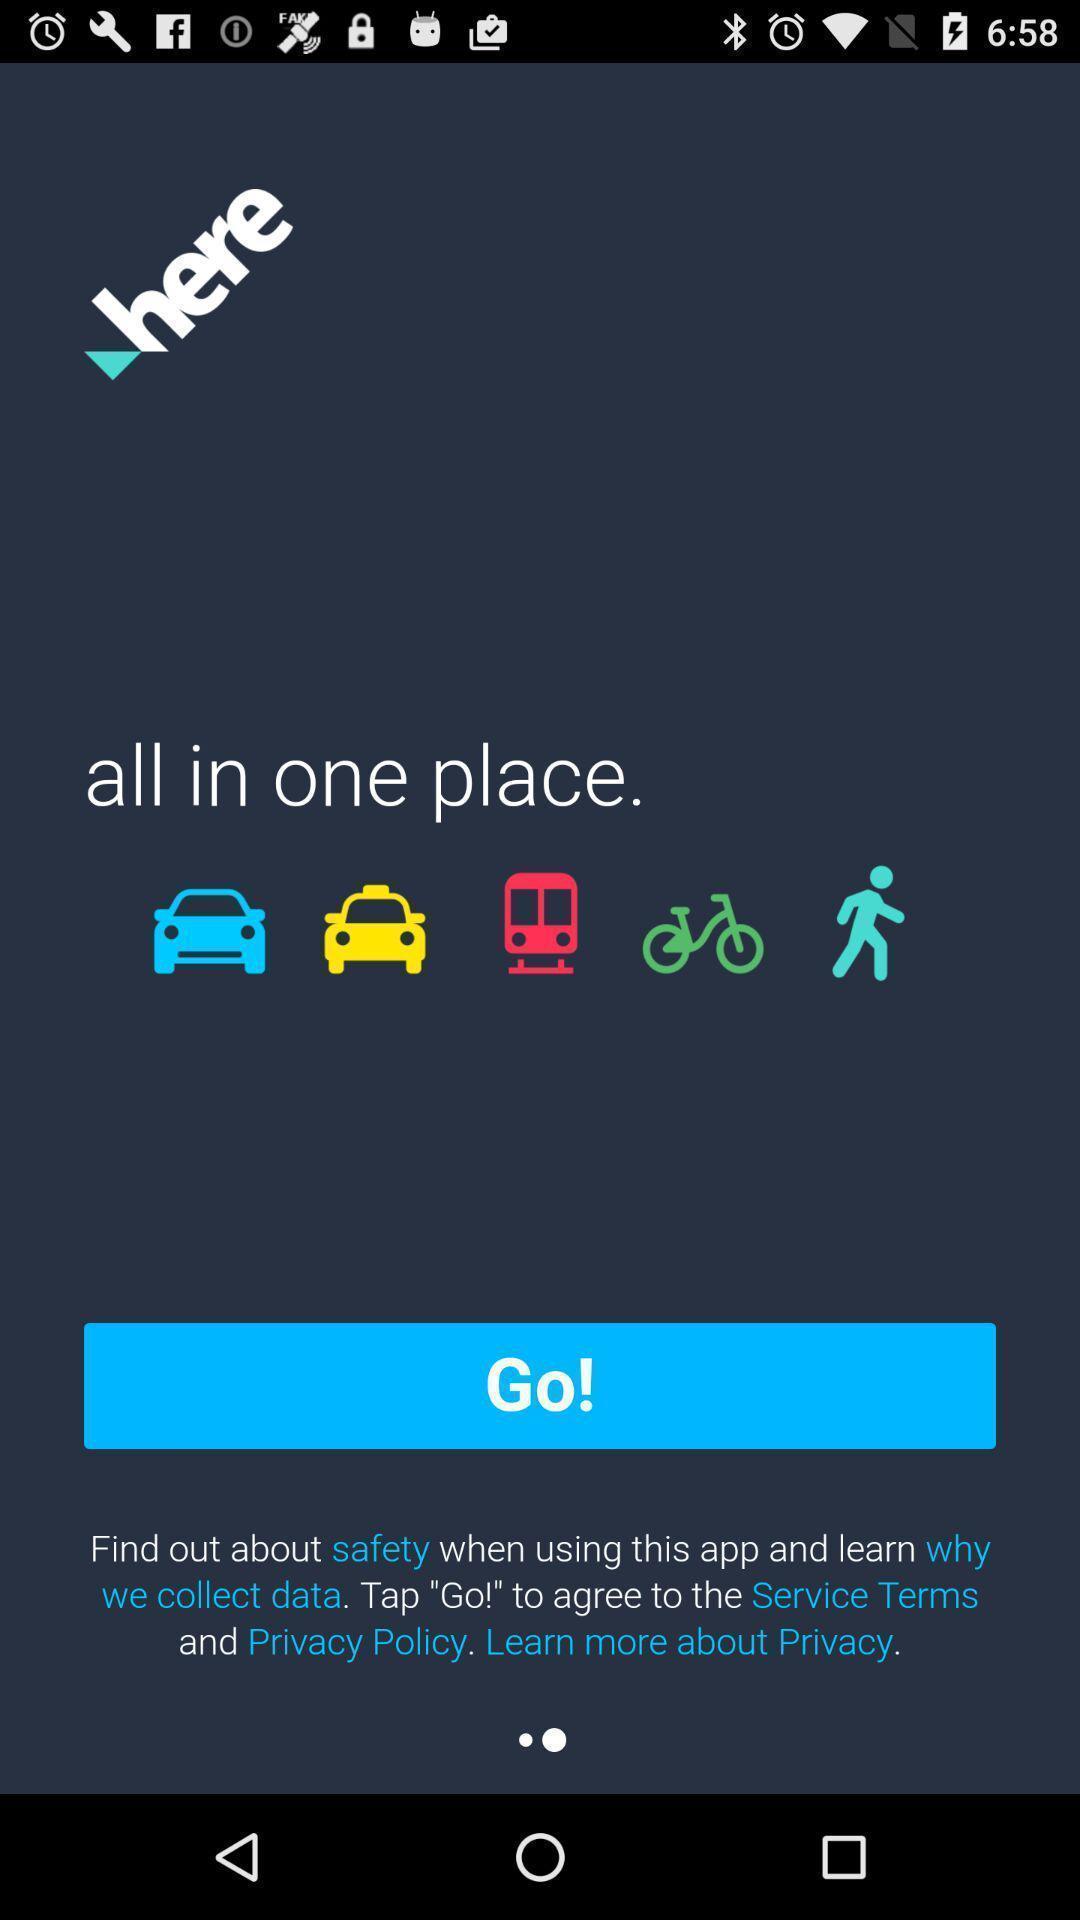Please provide a description for this image. Welcome page to get started in an education application. 